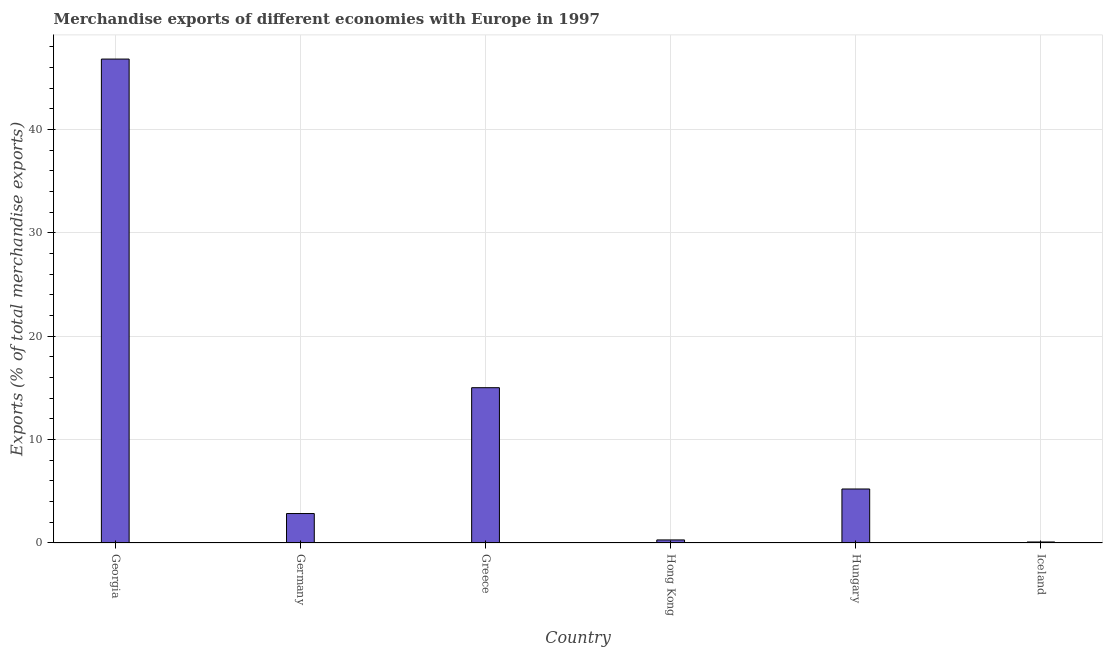Does the graph contain any zero values?
Give a very brief answer. No. Does the graph contain grids?
Your answer should be compact. Yes. What is the title of the graph?
Ensure brevity in your answer.  Merchandise exports of different economies with Europe in 1997. What is the label or title of the Y-axis?
Keep it short and to the point. Exports (% of total merchandise exports). What is the merchandise exports in Hungary?
Ensure brevity in your answer.  5.23. Across all countries, what is the maximum merchandise exports?
Your answer should be very brief. 46.83. Across all countries, what is the minimum merchandise exports?
Provide a succinct answer. 0.1. In which country was the merchandise exports maximum?
Provide a short and direct response. Georgia. What is the sum of the merchandise exports?
Give a very brief answer. 70.32. What is the difference between the merchandise exports in Greece and Hong Kong?
Keep it short and to the point. 14.73. What is the average merchandise exports per country?
Provide a succinct answer. 11.72. What is the median merchandise exports?
Offer a terse response. 4.04. In how many countries, is the merchandise exports greater than 14 %?
Your answer should be compact. 2. What is the ratio of the merchandise exports in Germany to that in Iceland?
Provide a short and direct response. 29.07. Is the merchandise exports in Greece less than that in Hungary?
Offer a very short reply. No. Is the difference between the merchandise exports in Hungary and Iceland greater than the difference between any two countries?
Offer a terse response. No. What is the difference between the highest and the second highest merchandise exports?
Your answer should be compact. 31.8. Is the sum of the merchandise exports in Georgia and Greece greater than the maximum merchandise exports across all countries?
Provide a short and direct response. Yes. What is the difference between the highest and the lowest merchandise exports?
Provide a short and direct response. 46.73. In how many countries, is the merchandise exports greater than the average merchandise exports taken over all countries?
Offer a very short reply. 2. How many bars are there?
Offer a very short reply. 6. Are all the bars in the graph horizontal?
Give a very brief answer. No. How many countries are there in the graph?
Keep it short and to the point. 6. What is the difference between two consecutive major ticks on the Y-axis?
Your response must be concise. 10. What is the Exports (% of total merchandise exports) of Georgia?
Provide a short and direct response. 46.83. What is the Exports (% of total merchandise exports) of Germany?
Keep it short and to the point. 2.85. What is the Exports (% of total merchandise exports) in Greece?
Give a very brief answer. 15.03. What is the Exports (% of total merchandise exports) in Hong Kong?
Offer a terse response. 0.3. What is the Exports (% of total merchandise exports) in Hungary?
Give a very brief answer. 5.23. What is the Exports (% of total merchandise exports) in Iceland?
Give a very brief answer. 0.1. What is the difference between the Exports (% of total merchandise exports) in Georgia and Germany?
Your answer should be very brief. 43.98. What is the difference between the Exports (% of total merchandise exports) in Georgia and Greece?
Your response must be concise. 31.8. What is the difference between the Exports (% of total merchandise exports) in Georgia and Hong Kong?
Offer a very short reply. 46.53. What is the difference between the Exports (% of total merchandise exports) in Georgia and Hungary?
Provide a short and direct response. 41.6. What is the difference between the Exports (% of total merchandise exports) in Georgia and Iceland?
Offer a terse response. 46.73. What is the difference between the Exports (% of total merchandise exports) in Germany and Greece?
Ensure brevity in your answer.  -12.18. What is the difference between the Exports (% of total merchandise exports) in Germany and Hong Kong?
Your answer should be compact. 2.55. What is the difference between the Exports (% of total merchandise exports) in Germany and Hungary?
Offer a very short reply. -2.38. What is the difference between the Exports (% of total merchandise exports) in Germany and Iceland?
Your response must be concise. 2.75. What is the difference between the Exports (% of total merchandise exports) in Greece and Hong Kong?
Your response must be concise. 14.73. What is the difference between the Exports (% of total merchandise exports) in Greece and Hungary?
Offer a terse response. 9.8. What is the difference between the Exports (% of total merchandise exports) in Greece and Iceland?
Keep it short and to the point. 14.93. What is the difference between the Exports (% of total merchandise exports) in Hong Kong and Hungary?
Your response must be concise. -4.93. What is the difference between the Exports (% of total merchandise exports) in Hong Kong and Iceland?
Offer a very short reply. 0.2. What is the difference between the Exports (% of total merchandise exports) in Hungary and Iceland?
Your response must be concise. 5.13. What is the ratio of the Exports (% of total merchandise exports) in Georgia to that in Germany?
Give a very brief answer. 16.43. What is the ratio of the Exports (% of total merchandise exports) in Georgia to that in Greece?
Your response must be concise. 3.12. What is the ratio of the Exports (% of total merchandise exports) in Georgia to that in Hong Kong?
Give a very brief answer. 158.04. What is the ratio of the Exports (% of total merchandise exports) in Georgia to that in Hungary?
Ensure brevity in your answer.  8.96. What is the ratio of the Exports (% of total merchandise exports) in Georgia to that in Iceland?
Your answer should be very brief. 477.58. What is the ratio of the Exports (% of total merchandise exports) in Germany to that in Greece?
Provide a short and direct response. 0.19. What is the ratio of the Exports (% of total merchandise exports) in Germany to that in Hong Kong?
Keep it short and to the point. 9.62. What is the ratio of the Exports (% of total merchandise exports) in Germany to that in Hungary?
Your answer should be very brief. 0.55. What is the ratio of the Exports (% of total merchandise exports) in Germany to that in Iceland?
Your answer should be compact. 29.07. What is the ratio of the Exports (% of total merchandise exports) in Greece to that in Hong Kong?
Provide a succinct answer. 50.72. What is the ratio of the Exports (% of total merchandise exports) in Greece to that in Hungary?
Make the answer very short. 2.88. What is the ratio of the Exports (% of total merchandise exports) in Greece to that in Iceland?
Provide a succinct answer. 153.27. What is the ratio of the Exports (% of total merchandise exports) in Hong Kong to that in Hungary?
Your answer should be compact. 0.06. What is the ratio of the Exports (% of total merchandise exports) in Hong Kong to that in Iceland?
Provide a succinct answer. 3.02. What is the ratio of the Exports (% of total merchandise exports) in Hungary to that in Iceland?
Offer a terse response. 53.3. 